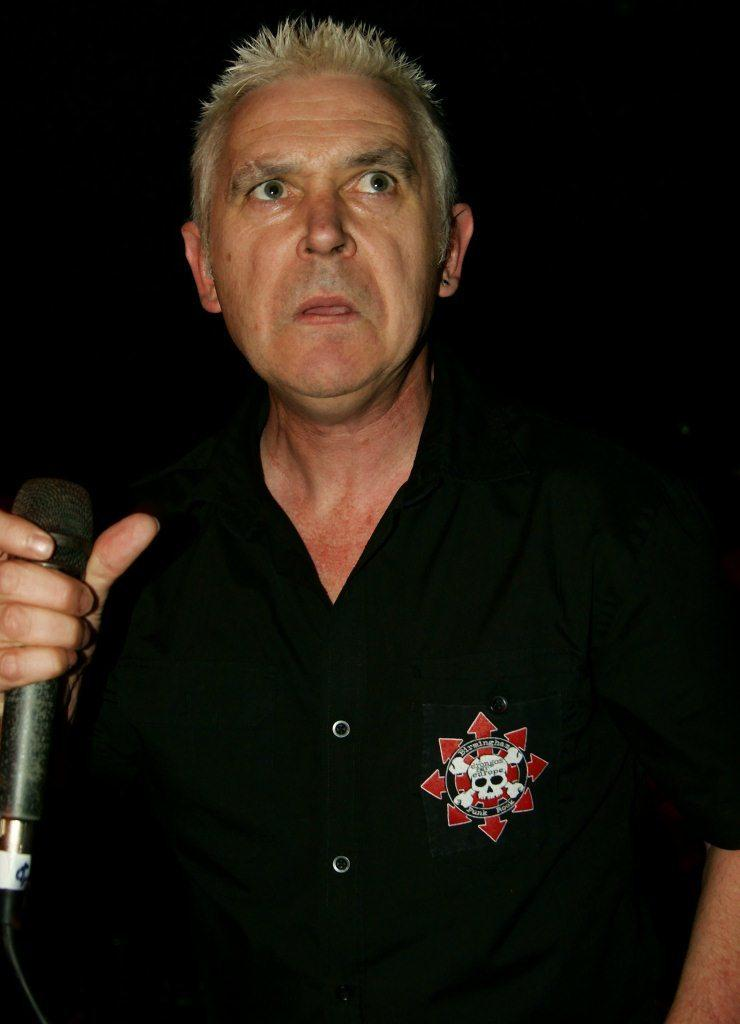Who is in the image? There is a man in the image. What is the man doing in the image? The man is standing in the image. What object is the man holding in the image? The man is holding a microphone in the image. What is the color of the microphone? The microphone is black in color. What type of meat is being served on a plate in the image? There is no plate or meat present in the image; it only features a man holding a black microphone. 